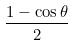Convert formula to latex. <formula><loc_0><loc_0><loc_500><loc_500>\frac { 1 - \cos \theta } { 2 }</formula> 